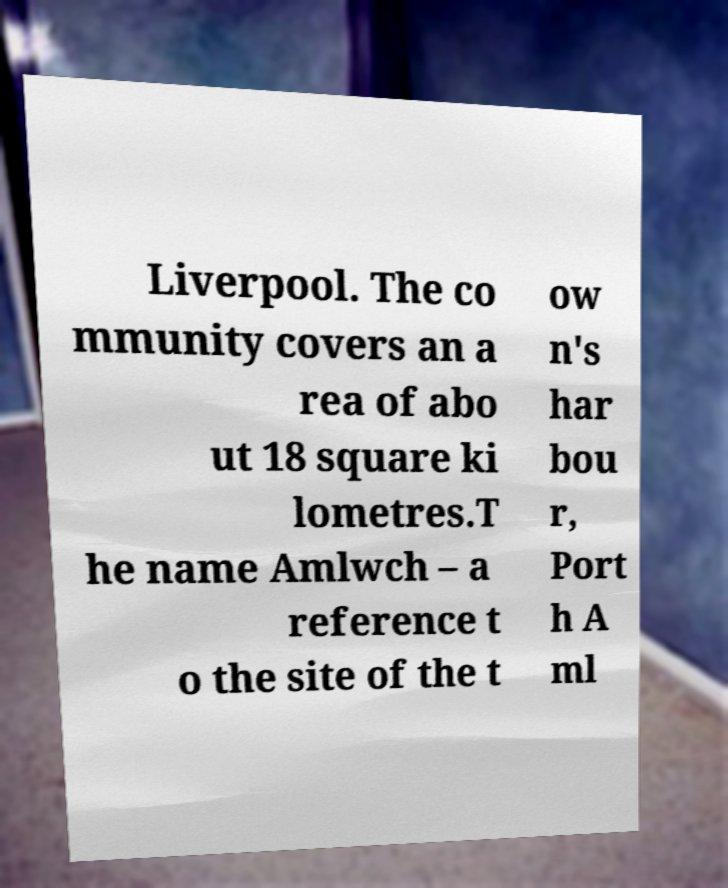There's text embedded in this image that I need extracted. Can you transcribe it verbatim? Liverpool. The co mmunity covers an a rea of abo ut 18 square ki lometres.T he name Amlwch – a reference t o the site of the t ow n's har bou r, Port h A ml 